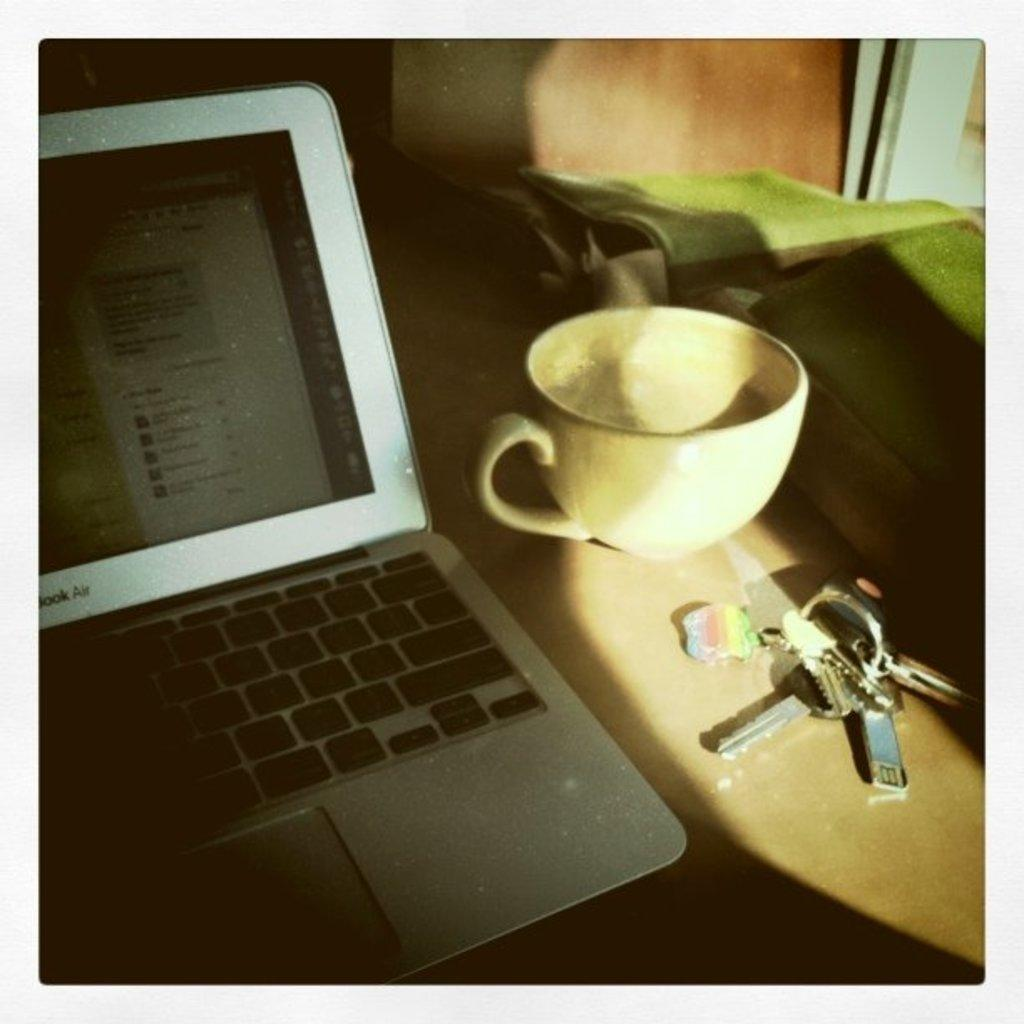What is one of the objects visible in the image? There is a cup in the image. What else can be seen on the table in the image? There are keys and a laptop visible in the image. Where are all the objects located in the image? All objects are on a table in the image. What type of picture is hanging on the wall in the image? There is no mention of a picture or a wall in the image, so it cannot be determined if there is a picture hanging on the wall. 